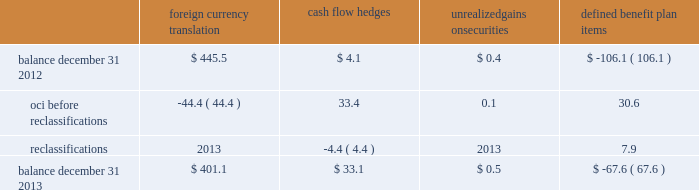Zimmer holdings , inc .
2013 form 10-k annual report notes to consolidated financial statements ( continued ) we have four tranches of senior notes outstanding : $ 250 million aggregate principal amount of 1.4 percent notes due november 30 , 2014 , $ 500 million aggregate principal amount of 4.625 percent notes due november 30 , 2019 , $ 300 million aggregate principal amount of 3.375 percent notes due november 30 , 2021 and $ 500 million aggregate principal amount of 5.75 percent notes due november 30 , 2039 .
Interest on each series is payable on may 30 and november 30 of each year until maturity .
The estimated fair value of our senior notes as of december 31 , 2013 , based on quoted prices for the specific securities from transactions in over-the-counter markets ( level 2 ) , was $ 1649.5 million .
We may redeem the senior notes at our election in whole or in part at any time prior to maturity at a redemption price equal to the greater of 1 ) 100 percent of the principal amount of the notes being redeemed ; or 2 ) the sum of the present values of the remaining scheduled payments of principal and interest ( not including any portion of such payments of interest accrued as of the date of redemption ) , discounted to the date of redemption on a semi-annual basis at the treasury rate ( as defined in the debt agreement ) , plus 15 basis points in the case of the 2014 notes , 20 basis points in the case of the 2019 notes and 2021 notes , and 25 basis points in the case of the 2039 notes .
We would also pay the accrued and unpaid interest on the senior notes to the redemption date .
We have entered into interest rate swap agreements which we designated as fair value hedges of underlying fixed- rate obligations on our senior notes due 2019 and 2021 .
See note 13 for additional information regarding the interest rate swap agreements .
Before our senior notes due november 30 , 2014 become payable , we intend to issue new senior notes in order to pay the $ 250 million owed .
If we are not able to issue new senior notes , we intend to borrow against our senior credit facility to pay these notes .
Since we have the ability and intent to refinance these senior notes on a long-term basis with new notes or through our senior credit facility , we have classified these senior notes as long-term debt as of december 31 , 2013 .
We also have available uncommitted credit facilities totaling $ 50.7 million .
At december 31 , 2013 , the weighted average interest rate for our long-term borrowings was 3.3 percent .
At december 31 , 2012 , the weighted average interest rate for short-term and long-term borrowings was 1.1 percent and 3.5 percent , respectively .
We paid $ 68.1 million , $ 67.8 million and $ 55.0 million in interest during 2013 , 2012 and 2011 , respectively .
12 .
Accumulated other comprehensive income oci refers to certain gains and losses that under gaap are included in comprehensive income but are excluded from net earnings as these amounts are initially recorded as an adjustment to stockholders 2019 equity .
Amounts in oci may be reclassified to net earnings upon the occurrence of certain events .
Our oci is comprised of foreign currency translation adjustments , unrealized gains and losses on cash flow hedges , unrealized gains and losses on available-for-sale securities , and amortization of prior service costs and unrecognized gains and losses in actuarial assumptions on our defined benefit plans .
Foreign currency translation adjustments are reclassified to net earnings upon sale or upon a complete or substantially complete liquidation of an investment in a foreign entity .
Unrealized gains and losses on cash flow hedges are reclassified to net earnings when the hedged item affects net earnings .
Unrealized gains and losses on available-for-sale securities are reclassified to net earnings if we sell the security before maturity or if the unrealized loss is considered to be other-than-temporary .
We typically hold our available-for-sale securities until maturity and are able to realize their amortized cost and therefore we do not have reclassification adjustments to net earnings on these securities .
Amounts related to defined benefit plans that are in oci are reclassified over the service periods of employees in the plan .
The reclassification amounts are allocated to all employees in the plans and therefore the reclassified amounts may become part of inventory to the extent they are considered direct labor costs .
See note 14 for more information on our defined benefit plans .
The table shows the changes in the components of oci , net of tax ( in millions ) : foreign currency translation hedges unrealized gains on securities defined benefit .

What was the change in interest paid between 2011 and 2012 in millions? 
Computations: (67.8 - 55.0)
Answer: 12.8. 